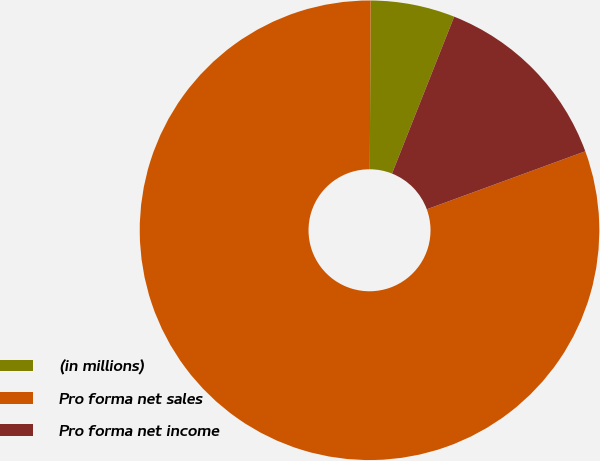Convert chart to OTSL. <chart><loc_0><loc_0><loc_500><loc_500><pie_chart><fcel>(in millions)<fcel>Pro forma net sales<fcel>Pro forma net income<nl><fcel>5.93%<fcel>80.66%<fcel>13.41%<nl></chart> 